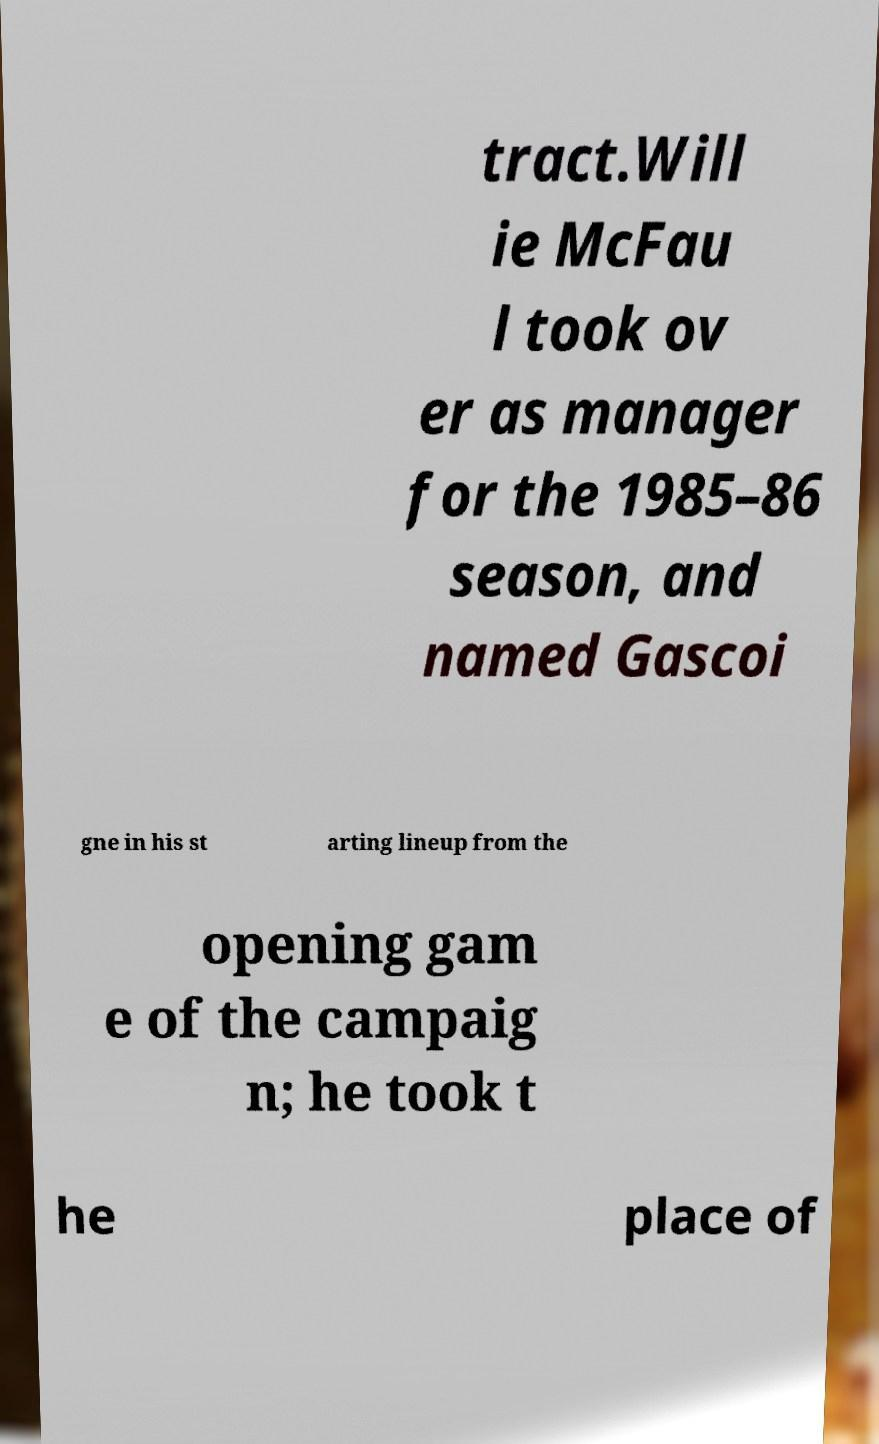What messages or text are displayed in this image? I need them in a readable, typed format. tract.Will ie McFau l took ov er as manager for the 1985–86 season, and named Gascoi gne in his st arting lineup from the opening gam e of the campaig n; he took t he place of 